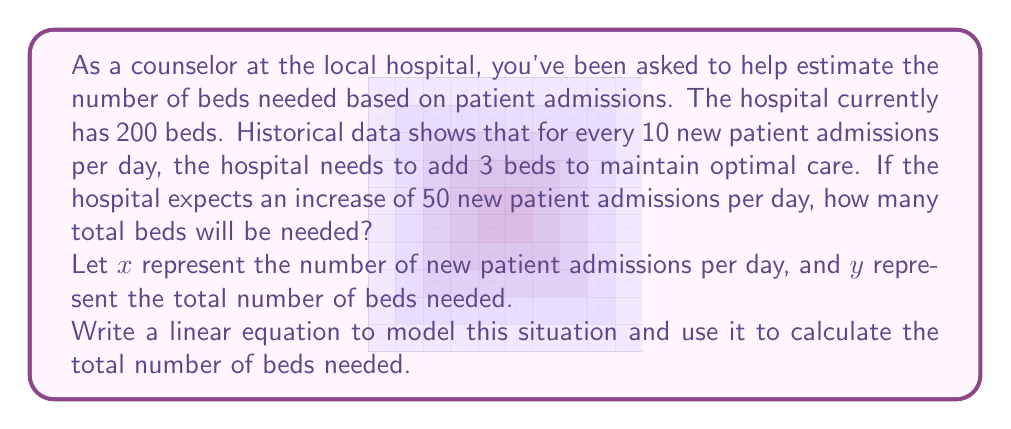Teach me how to tackle this problem. To solve this problem, we'll follow these steps:

1) First, let's identify the important information:
   - The hospital currently has 200 beds
   - For every 10 new admissions, 3 beds need to be added
   - The expected increase is 50 new admissions per day

2) Now, let's set up our linear equation:
   - The slope of our line will be 3/10 (3 beds for every 10 admissions)
   - The y-intercept is 200 (the current number of beds)

   Our linear equation is:

   $$ y = \frac{3}{10}x + 200 $$

   Where $y$ is the total number of beds needed and $x$ is the number of new admissions per day.

3) We want to find $y$ when $x = 50$ (the expected increase in admissions). Let's substitute this into our equation:

   $$ y = \frac{3}{10}(50) + 200 $$

4) Now, let's solve:
   $$ y = 15 + 200 = 215 $$

Therefore, the hospital will need a total of 215 beds to accommodate the increase in admissions.
Answer: 215 beds 